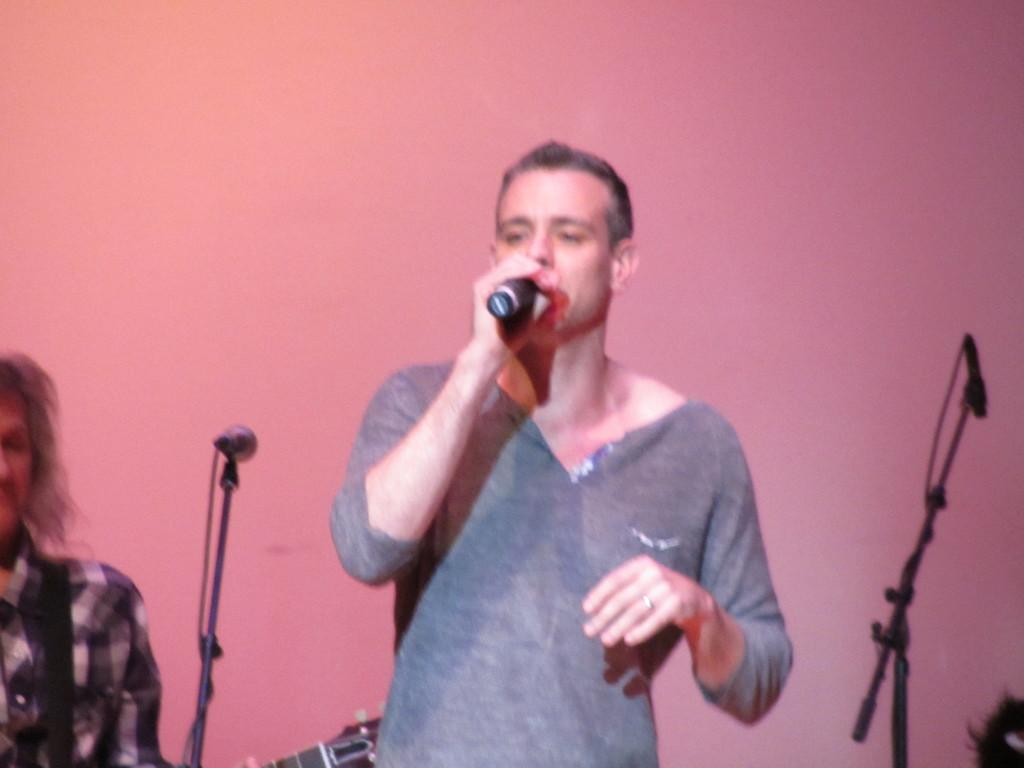Who is the main subject in the image? There is a man in the image. What is the man doing in the image? The man is talking on a microphone. How many microphones are visible in the image? There are microphones in the image. What can be seen in the background of the image? There is a wall in the image. What type of zebra can be seen eating oranges in the image? There is no zebra or oranges present in the image. 